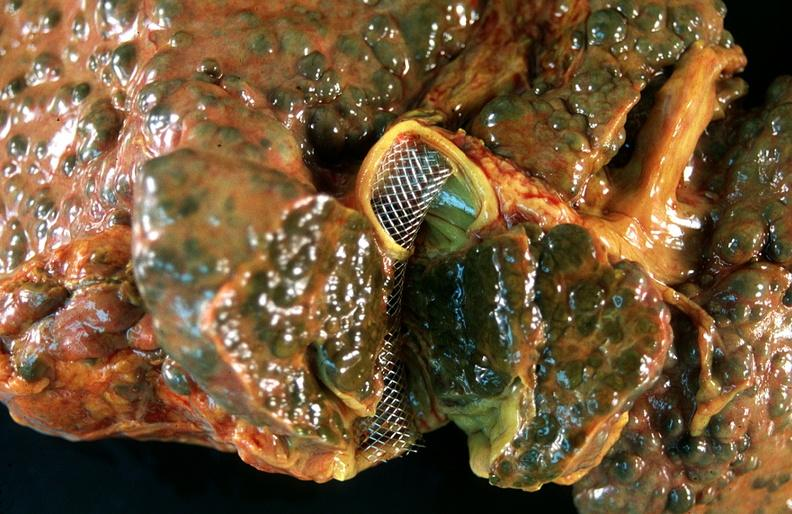what is present?
Answer the question using a single word or phrase. Hepatobiliary 